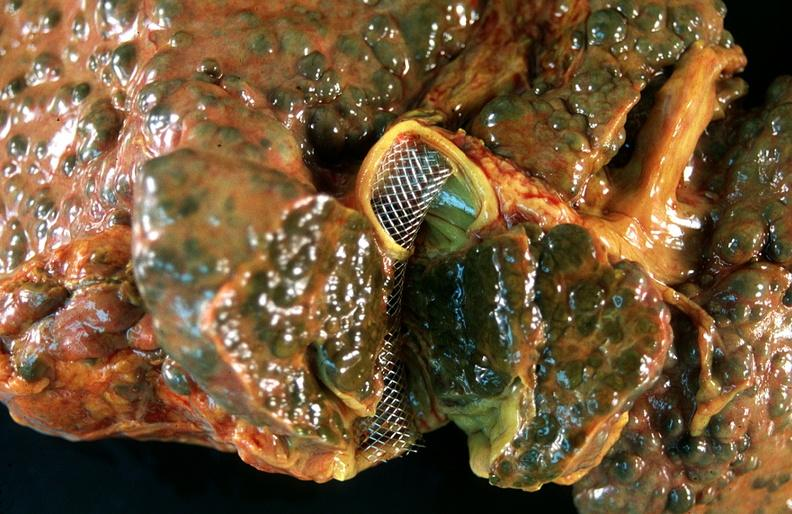what is present?
Answer the question using a single word or phrase. Hepatobiliary 